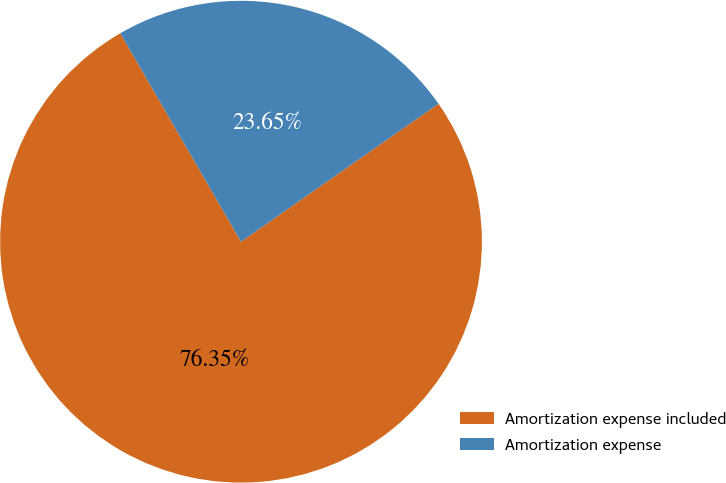<chart> <loc_0><loc_0><loc_500><loc_500><pie_chart><fcel>Amortization expense included<fcel>Amortization expense<nl><fcel>76.35%<fcel>23.65%<nl></chart> 